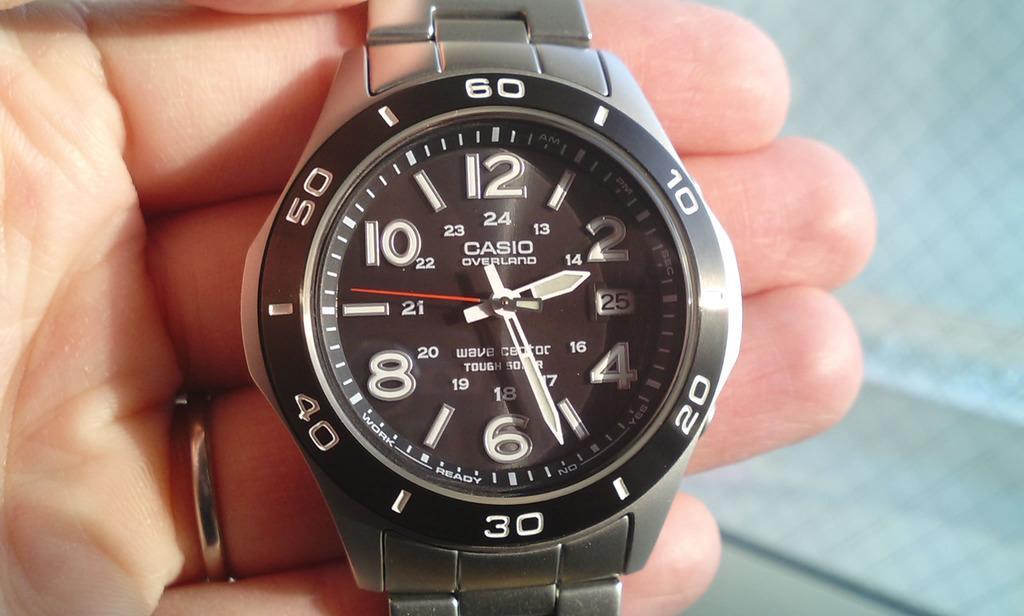What object is present in the image that is typically used for telling time? There is a watch in the image. What part of the human body is visible in the image? Human fingers are visible in the image. What type of material or design can be seen on the backside of the watch? There is a net on the backside in the image. What type of grain is being harvested in the image? There is no grain present in the image. How does the brain of the person in the image process the information from the watch? The image does not show a person's brain or provide any information about how the watch is being processed or perceived. 